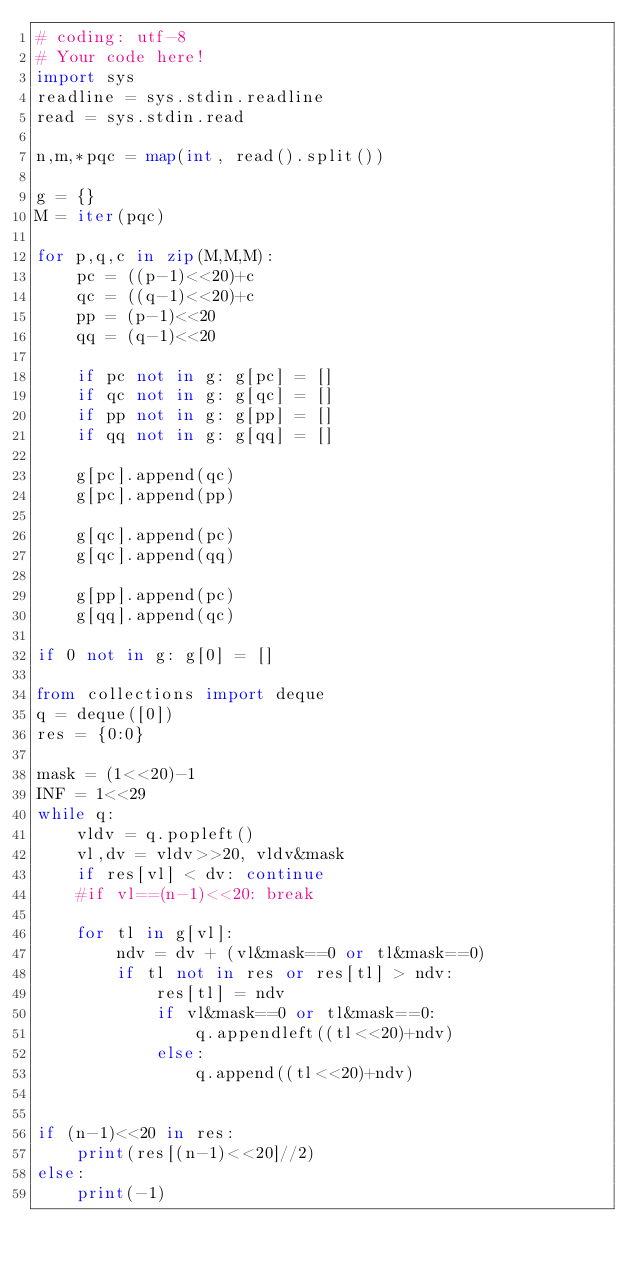Convert code to text. <code><loc_0><loc_0><loc_500><loc_500><_Python_># coding: utf-8
# Your code here!
import sys
readline = sys.stdin.readline
read = sys.stdin.read

n,m,*pqc = map(int, read().split())

g = {}
M = iter(pqc)

for p,q,c in zip(M,M,M):
    pc = ((p-1)<<20)+c
    qc = ((q-1)<<20)+c
    pp = (p-1)<<20
    qq = (q-1)<<20
    
    if pc not in g: g[pc] = []
    if qc not in g: g[qc] = []
    if pp not in g: g[pp] = []
    if qq not in g: g[qq] = []
    
    g[pc].append(qc)
    g[pc].append(pp)

    g[qc].append(pc)
    g[qc].append(qq)

    g[pp].append(pc)
    g[qq].append(qc)

if 0 not in g: g[0] = []

from collections import deque
q = deque([0])
res = {0:0}

mask = (1<<20)-1
INF = 1<<29
while q:
    vldv = q.popleft()
    vl,dv = vldv>>20, vldv&mask
    if res[vl] < dv: continue
    #if vl==(n-1)<<20: break

    for tl in g[vl]:
        ndv = dv + (vl&mask==0 or tl&mask==0)
        if tl not in res or res[tl] > ndv:
            res[tl] = ndv
            if vl&mask==0 or tl&mask==0:
                q.appendleft((tl<<20)+ndv)
            else:
                q.append((tl<<20)+ndv)
            

if (n-1)<<20 in res:
    print(res[(n-1)<<20]//2)
else:
    print(-1)




</code> 